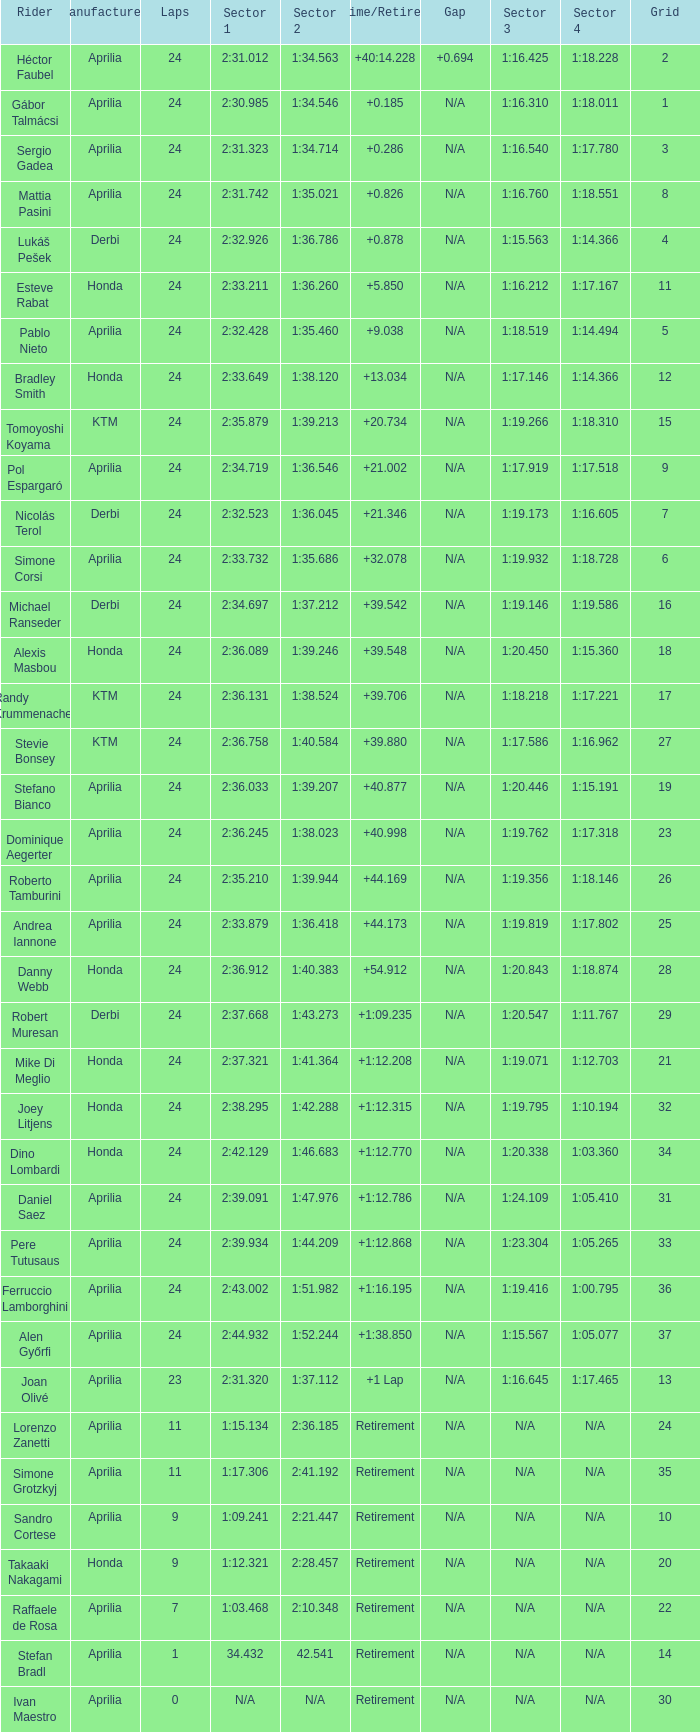How many grids have more than 24 laps with a time/retired of +1:12.208? None. 